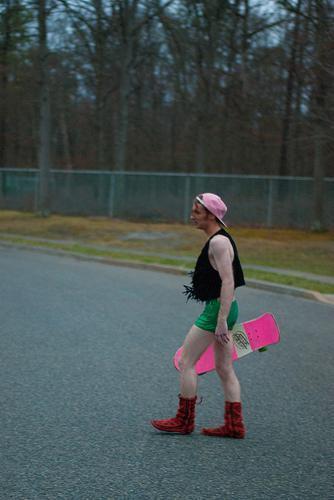How many skateboards are there?
Give a very brief answer. 1. How many wheels are seen?
Give a very brief answer. 1. How many pink shorts are in the photo?
Give a very brief answer. 0. 